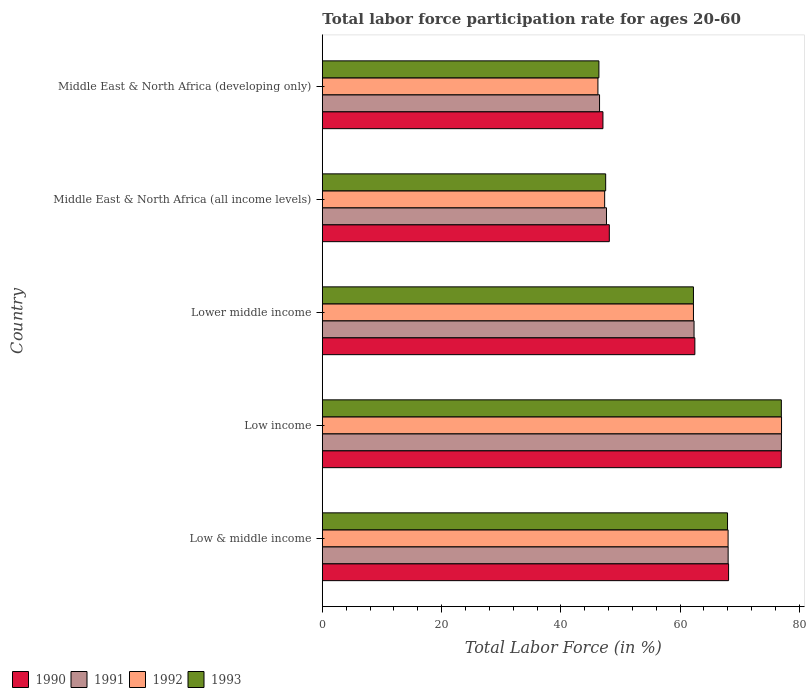How many different coloured bars are there?
Keep it short and to the point. 4. Are the number of bars per tick equal to the number of legend labels?
Provide a short and direct response. Yes. In how many cases, is the number of bars for a given country not equal to the number of legend labels?
Offer a very short reply. 0. What is the labor force participation rate in 1991 in Middle East & North Africa (developing only)?
Your answer should be compact. 46.49. Across all countries, what is the maximum labor force participation rate in 1990?
Provide a short and direct response. 76.96. Across all countries, what is the minimum labor force participation rate in 1991?
Your answer should be very brief. 46.49. In which country was the labor force participation rate in 1991 minimum?
Give a very brief answer. Middle East & North Africa (developing only). What is the total labor force participation rate in 1992 in the graph?
Offer a very short reply. 300.85. What is the difference between the labor force participation rate in 1991 in Low & middle income and that in Low income?
Ensure brevity in your answer.  -8.94. What is the difference between the labor force participation rate in 1992 in Middle East & North Africa (all income levels) and the labor force participation rate in 1990 in Low income?
Offer a very short reply. -29.62. What is the average labor force participation rate in 1993 per country?
Give a very brief answer. 60.21. What is the difference between the labor force participation rate in 1991 and labor force participation rate in 1992 in Middle East & North Africa (all income levels)?
Keep it short and to the point. 0.31. What is the ratio of the labor force participation rate in 1992 in Low & middle income to that in Middle East & North Africa (developing only)?
Offer a very short reply. 1.47. What is the difference between the highest and the second highest labor force participation rate in 1993?
Give a very brief answer. 9.03. What is the difference between the highest and the lowest labor force participation rate in 1991?
Keep it short and to the point. 30.5. What does the 4th bar from the top in Middle East & North Africa (developing only) represents?
Keep it short and to the point. 1990. What does the 1st bar from the bottom in Middle East & North Africa (developing only) represents?
Keep it short and to the point. 1990. Is it the case that in every country, the sum of the labor force participation rate in 1991 and labor force participation rate in 1993 is greater than the labor force participation rate in 1992?
Make the answer very short. Yes. How many bars are there?
Make the answer very short. 20. Are all the bars in the graph horizontal?
Offer a very short reply. Yes. What is the difference between two consecutive major ticks on the X-axis?
Provide a succinct answer. 20. Does the graph contain grids?
Your response must be concise. No. Where does the legend appear in the graph?
Provide a short and direct response. Bottom left. How many legend labels are there?
Make the answer very short. 4. What is the title of the graph?
Ensure brevity in your answer.  Total labor force participation rate for ages 20-60. Does "2010" appear as one of the legend labels in the graph?
Your answer should be compact. No. What is the label or title of the Y-axis?
Your answer should be compact. Country. What is the Total Labor Force (in %) of 1990 in Low & middle income?
Ensure brevity in your answer.  68.13. What is the Total Labor Force (in %) in 1991 in Low & middle income?
Provide a succinct answer. 68.05. What is the Total Labor Force (in %) of 1992 in Low & middle income?
Offer a terse response. 68.05. What is the Total Labor Force (in %) in 1993 in Low & middle income?
Offer a very short reply. 67.95. What is the Total Labor Force (in %) in 1990 in Low income?
Your answer should be compact. 76.96. What is the Total Labor Force (in %) of 1991 in Low income?
Give a very brief answer. 76.99. What is the Total Labor Force (in %) of 1992 in Low income?
Ensure brevity in your answer.  77.01. What is the Total Labor Force (in %) in 1993 in Low income?
Make the answer very short. 76.98. What is the Total Labor Force (in %) of 1990 in Lower middle income?
Keep it short and to the point. 62.47. What is the Total Labor Force (in %) of 1991 in Lower middle income?
Your response must be concise. 62.34. What is the Total Labor Force (in %) of 1992 in Lower middle income?
Ensure brevity in your answer.  62.24. What is the Total Labor Force (in %) of 1993 in Lower middle income?
Give a very brief answer. 62.24. What is the Total Labor Force (in %) of 1990 in Middle East & North Africa (all income levels)?
Make the answer very short. 48.13. What is the Total Labor Force (in %) in 1991 in Middle East & North Africa (all income levels)?
Your answer should be very brief. 47.65. What is the Total Labor Force (in %) in 1992 in Middle East & North Africa (all income levels)?
Ensure brevity in your answer.  47.34. What is the Total Labor Force (in %) in 1993 in Middle East & North Africa (all income levels)?
Provide a short and direct response. 47.51. What is the Total Labor Force (in %) of 1990 in Middle East & North Africa (developing only)?
Offer a terse response. 47.06. What is the Total Labor Force (in %) of 1991 in Middle East & North Africa (developing only)?
Make the answer very short. 46.49. What is the Total Labor Force (in %) in 1992 in Middle East & North Africa (developing only)?
Provide a short and direct response. 46.22. What is the Total Labor Force (in %) in 1993 in Middle East & North Africa (developing only)?
Keep it short and to the point. 46.38. Across all countries, what is the maximum Total Labor Force (in %) in 1990?
Give a very brief answer. 76.96. Across all countries, what is the maximum Total Labor Force (in %) of 1991?
Your answer should be compact. 76.99. Across all countries, what is the maximum Total Labor Force (in %) in 1992?
Offer a very short reply. 77.01. Across all countries, what is the maximum Total Labor Force (in %) of 1993?
Your answer should be very brief. 76.98. Across all countries, what is the minimum Total Labor Force (in %) in 1990?
Provide a succinct answer. 47.06. Across all countries, what is the minimum Total Labor Force (in %) in 1991?
Provide a short and direct response. 46.49. Across all countries, what is the minimum Total Labor Force (in %) in 1992?
Provide a succinct answer. 46.22. Across all countries, what is the minimum Total Labor Force (in %) in 1993?
Your answer should be compact. 46.38. What is the total Total Labor Force (in %) of 1990 in the graph?
Your response must be concise. 302.75. What is the total Total Labor Force (in %) in 1991 in the graph?
Give a very brief answer. 301.52. What is the total Total Labor Force (in %) of 1992 in the graph?
Give a very brief answer. 300.85. What is the total Total Labor Force (in %) in 1993 in the graph?
Your answer should be very brief. 301.06. What is the difference between the Total Labor Force (in %) in 1990 in Low & middle income and that in Low income?
Give a very brief answer. -8.84. What is the difference between the Total Labor Force (in %) of 1991 in Low & middle income and that in Low income?
Provide a short and direct response. -8.94. What is the difference between the Total Labor Force (in %) in 1992 in Low & middle income and that in Low income?
Your response must be concise. -8.96. What is the difference between the Total Labor Force (in %) of 1993 in Low & middle income and that in Low income?
Offer a terse response. -9.03. What is the difference between the Total Labor Force (in %) in 1990 in Low & middle income and that in Lower middle income?
Provide a succinct answer. 5.65. What is the difference between the Total Labor Force (in %) of 1991 in Low & middle income and that in Lower middle income?
Your answer should be very brief. 5.72. What is the difference between the Total Labor Force (in %) in 1992 in Low & middle income and that in Lower middle income?
Keep it short and to the point. 5.81. What is the difference between the Total Labor Force (in %) of 1993 in Low & middle income and that in Lower middle income?
Your answer should be very brief. 5.71. What is the difference between the Total Labor Force (in %) of 1990 in Low & middle income and that in Middle East & North Africa (all income levels)?
Keep it short and to the point. 20. What is the difference between the Total Labor Force (in %) of 1991 in Low & middle income and that in Middle East & North Africa (all income levels)?
Give a very brief answer. 20.4. What is the difference between the Total Labor Force (in %) in 1992 in Low & middle income and that in Middle East & North Africa (all income levels)?
Provide a succinct answer. 20.7. What is the difference between the Total Labor Force (in %) of 1993 in Low & middle income and that in Middle East & North Africa (all income levels)?
Ensure brevity in your answer.  20.44. What is the difference between the Total Labor Force (in %) in 1990 in Low & middle income and that in Middle East & North Africa (developing only)?
Your response must be concise. 21.07. What is the difference between the Total Labor Force (in %) of 1991 in Low & middle income and that in Middle East & North Africa (developing only)?
Provide a short and direct response. 21.56. What is the difference between the Total Labor Force (in %) in 1992 in Low & middle income and that in Middle East & North Africa (developing only)?
Make the answer very short. 21.83. What is the difference between the Total Labor Force (in %) of 1993 in Low & middle income and that in Middle East & North Africa (developing only)?
Your response must be concise. 21.57. What is the difference between the Total Labor Force (in %) of 1990 in Low income and that in Lower middle income?
Ensure brevity in your answer.  14.49. What is the difference between the Total Labor Force (in %) in 1991 in Low income and that in Lower middle income?
Offer a very short reply. 14.65. What is the difference between the Total Labor Force (in %) of 1992 in Low income and that in Lower middle income?
Provide a short and direct response. 14.77. What is the difference between the Total Labor Force (in %) of 1993 in Low income and that in Lower middle income?
Give a very brief answer. 14.74. What is the difference between the Total Labor Force (in %) in 1990 in Low income and that in Middle East & North Africa (all income levels)?
Offer a very short reply. 28.84. What is the difference between the Total Labor Force (in %) in 1991 in Low income and that in Middle East & North Africa (all income levels)?
Offer a terse response. 29.34. What is the difference between the Total Labor Force (in %) of 1992 in Low income and that in Middle East & North Africa (all income levels)?
Provide a short and direct response. 29.66. What is the difference between the Total Labor Force (in %) of 1993 in Low income and that in Middle East & North Africa (all income levels)?
Your answer should be compact. 29.46. What is the difference between the Total Labor Force (in %) in 1990 in Low income and that in Middle East & North Africa (developing only)?
Keep it short and to the point. 29.91. What is the difference between the Total Labor Force (in %) in 1991 in Low income and that in Middle East & North Africa (developing only)?
Keep it short and to the point. 30.5. What is the difference between the Total Labor Force (in %) of 1992 in Low income and that in Middle East & North Africa (developing only)?
Your response must be concise. 30.79. What is the difference between the Total Labor Force (in %) of 1993 in Low income and that in Middle East & North Africa (developing only)?
Make the answer very short. 30.6. What is the difference between the Total Labor Force (in %) of 1990 in Lower middle income and that in Middle East & North Africa (all income levels)?
Your response must be concise. 14.35. What is the difference between the Total Labor Force (in %) of 1991 in Lower middle income and that in Middle East & North Africa (all income levels)?
Provide a short and direct response. 14.69. What is the difference between the Total Labor Force (in %) of 1992 in Lower middle income and that in Middle East & North Africa (all income levels)?
Your answer should be very brief. 14.89. What is the difference between the Total Labor Force (in %) of 1993 in Lower middle income and that in Middle East & North Africa (all income levels)?
Your answer should be compact. 14.72. What is the difference between the Total Labor Force (in %) in 1990 in Lower middle income and that in Middle East & North Africa (developing only)?
Your answer should be compact. 15.41. What is the difference between the Total Labor Force (in %) in 1991 in Lower middle income and that in Middle East & North Africa (developing only)?
Offer a terse response. 15.85. What is the difference between the Total Labor Force (in %) in 1992 in Lower middle income and that in Middle East & North Africa (developing only)?
Provide a succinct answer. 16.02. What is the difference between the Total Labor Force (in %) in 1993 in Lower middle income and that in Middle East & North Africa (developing only)?
Ensure brevity in your answer.  15.86. What is the difference between the Total Labor Force (in %) in 1990 in Middle East & North Africa (all income levels) and that in Middle East & North Africa (developing only)?
Provide a short and direct response. 1.07. What is the difference between the Total Labor Force (in %) of 1991 in Middle East & North Africa (all income levels) and that in Middle East & North Africa (developing only)?
Keep it short and to the point. 1.16. What is the difference between the Total Labor Force (in %) of 1992 in Middle East & North Africa (all income levels) and that in Middle East & North Africa (developing only)?
Keep it short and to the point. 1.13. What is the difference between the Total Labor Force (in %) of 1993 in Middle East & North Africa (all income levels) and that in Middle East & North Africa (developing only)?
Keep it short and to the point. 1.13. What is the difference between the Total Labor Force (in %) in 1990 in Low & middle income and the Total Labor Force (in %) in 1991 in Low income?
Give a very brief answer. -8.86. What is the difference between the Total Labor Force (in %) in 1990 in Low & middle income and the Total Labor Force (in %) in 1992 in Low income?
Provide a short and direct response. -8.88. What is the difference between the Total Labor Force (in %) of 1990 in Low & middle income and the Total Labor Force (in %) of 1993 in Low income?
Your answer should be compact. -8.85. What is the difference between the Total Labor Force (in %) of 1991 in Low & middle income and the Total Labor Force (in %) of 1992 in Low income?
Offer a terse response. -8.95. What is the difference between the Total Labor Force (in %) of 1991 in Low & middle income and the Total Labor Force (in %) of 1993 in Low income?
Keep it short and to the point. -8.92. What is the difference between the Total Labor Force (in %) in 1992 in Low & middle income and the Total Labor Force (in %) in 1993 in Low income?
Your response must be concise. -8.93. What is the difference between the Total Labor Force (in %) of 1990 in Low & middle income and the Total Labor Force (in %) of 1991 in Lower middle income?
Offer a very short reply. 5.79. What is the difference between the Total Labor Force (in %) of 1990 in Low & middle income and the Total Labor Force (in %) of 1992 in Lower middle income?
Your answer should be compact. 5.89. What is the difference between the Total Labor Force (in %) of 1990 in Low & middle income and the Total Labor Force (in %) of 1993 in Lower middle income?
Your answer should be compact. 5.89. What is the difference between the Total Labor Force (in %) in 1991 in Low & middle income and the Total Labor Force (in %) in 1992 in Lower middle income?
Offer a terse response. 5.82. What is the difference between the Total Labor Force (in %) of 1991 in Low & middle income and the Total Labor Force (in %) of 1993 in Lower middle income?
Offer a terse response. 5.82. What is the difference between the Total Labor Force (in %) of 1992 in Low & middle income and the Total Labor Force (in %) of 1993 in Lower middle income?
Your answer should be compact. 5.81. What is the difference between the Total Labor Force (in %) of 1990 in Low & middle income and the Total Labor Force (in %) of 1991 in Middle East & North Africa (all income levels)?
Provide a short and direct response. 20.48. What is the difference between the Total Labor Force (in %) of 1990 in Low & middle income and the Total Labor Force (in %) of 1992 in Middle East & North Africa (all income levels)?
Your response must be concise. 20.78. What is the difference between the Total Labor Force (in %) in 1990 in Low & middle income and the Total Labor Force (in %) in 1993 in Middle East & North Africa (all income levels)?
Offer a terse response. 20.61. What is the difference between the Total Labor Force (in %) of 1991 in Low & middle income and the Total Labor Force (in %) of 1992 in Middle East & North Africa (all income levels)?
Offer a very short reply. 20.71. What is the difference between the Total Labor Force (in %) in 1991 in Low & middle income and the Total Labor Force (in %) in 1993 in Middle East & North Africa (all income levels)?
Offer a terse response. 20.54. What is the difference between the Total Labor Force (in %) of 1992 in Low & middle income and the Total Labor Force (in %) of 1993 in Middle East & North Africa (all income levels)?
Make the answer very short. 20.53. What is the difference between the Total Labor Force (in %) of 1990 in Low & middle income and the Total Labor Force (in %) of 1991 in Middle East & North Africa (developing only)?
Your answer should be compact. 21.64. What is the difference between the Total Labor Force (in %) in 1990 in Low & middle income and the Total Labor Force (in %) in 1992 in Middle East & North Africa (developing only)?
Give a very brief answer. 21.91. What is the difference between the Total Labor Force (in %) of 1990 in Low & middle income and the Total Labor Force (in %) of 1993 in Middle East & North Africa (developing only)?
Your response must be concise. 21.75. What is the difference between the Total Labor Force (in %) of 1991 in Low & middle income and the Total Labor Force (in %) of 1992 in Middle East & North Africa (developing only)?
Provide a short and direct response. 21.84. What is the difference between the Total Labor Force (in %) of 1991 in Low & middle income and the Total Labor Force (in %) of 1993 in Middle East & North Africa (developing only)?
Your answer should be very brief. 21.67. What is the difference between the Total Labor Force (in %) in 1992 in Low & middle income and the Total Labor Force (in %) in 1993 in Middle East & North Africa (developing only)?
Ensure brevity in your answer.  21.66. What is the difference between the Total Labor Force (in %) in 1990 in Low income and the Total Labor Force (in %) in 1991 in Lower middle income?
Make the answer very short. 14.63. What is the difference between the Total Labor Force (in %) in 1990 in Low income and the Total Labor Force (in %) in 1992 in Lower middle income?
Keep it short and to the point. 14.73. What is the difference between the Total Labor Force (in %) in 1990 in Low income and the Total Labor Force (in %) in 1993 in Lower middle income?
Give a very brief answer. 14.73. What is the difference between the Total Labor Force (in %) in 1991 in Low income and the Total Labor Force (in %) in 1992 in Lower middle income?
Provide a short and direct response. 14.75. What is the difference between the Total Labor Force (in %) in 1991 in Low income and the Total Labor Force (in %) in 1993 in Lower middle income?
Offer a terse response. 14.75. What is the difference between the Total Labor Force (in %) in 1992 in Low income and the Total Labor Force (in %) in 1993 in Lower middle income?
Provide a succinct answer. 14.77. What is the difference between the Total Labor Force (in %) of 1990 in Low income and the Total Labor Force (in %) of 1991 in Middle East & North Africa (all income levels)?
Give a very brief answer. 29.31. What is the difference between the Total Labor Force (in %) in 1990 in Low income and the Total Labor Force (in %) in 1992 in Middle East & North Africa (all income levels)?
Offer a terse response. 29.62. What is the difference between the Total Labor Force (in %) in 1990 in Low income and the Total Labor Force (in %) in 1993 in Middle East & North Africa (all income levels)?
Provide a short and direct response. 29.45. What is the difference between the Total Labor Force (in %) in 1991 in Low income and the Total Labor Force (in %) in 1992 in Middle East & North Africa (all income levels)?
Provide a succinct answer. 29.64. What is the difference between the Total Labor Force (in %) in 1991 in Low income and the Total Labor Force (in %) in 1993 in Middle East & North Africa (all income levels)?
Offer a terse response. 29.47. What is the difference between the Total Labor Force (in %) of 1992 in Low income and the Total Labor Force (in %) of 1993 in Middle East & North Africa (all income levels)?
Keep it short and to the point. 29.49. What is the difference between the Total Labor Force (in %) of 1990 in Low income and the Total Labor Force (in %) of 1991 in Middle East & North Africa (developing only)?
Provide a short and direct response. 30.47. What is the difference between the Total Labor Force (in %) of 1990 in Low income and the Total Labor Force (in %) of 1992 in Middle East & North Africa (developing only)?
Provide a short and direct response. 30.75. What is the difference between the Total Labor Force (in %) in 1990 in Low income and the Total Labor Force (in %) in 1993 in Middle East & North Africa (developing only)?
Make the answer very short. 30.58. What is the difference between the Total Labor Force (in %) of 1991 in Low income and the Total Labor Force (in %) of 1992 in Middle East & North Africa (developing only)?
Make the answer very short. 30.77. What is the difference between the Total Labor Force (in %) in 1991 in Low income and the Total Labor Force (in %) in 1993 in Middle East & North Africa (developing only)?
Ensure brevity in your answer.  30.61. What is the difference between the Total Labor Force (in %) of 1992 in Low income and the Total Labor Force (in %) of 1993 in Middle East & North Africa (developing only)?
Make the answer very short. 30.63. What is the difference between the Total Labor Force (in %) in 1990 in Lower middle income and the Total Labor Force (in %) in 1991 in Middle East & North Africa (all income levels)?
Offer a very short reply. 14.82. What is the difference between the Total Labor Force (in %) of 1990 in Lower middle income and the Total Labor Force (in %) of 1992 in Middle East & North Africa (all income levels)?
Offer a terse response. 15.13. What is the difference between the Total Labor Force (in %) of 1990 in Lower middle income and the Total Labor Force (in %) of 1993 in Middle East & North Africa (all income levels)?
Give a very brief answer. 14.96. What is the difference between the Total Labor Force (in %) of 1991 in Lower middle income and the Total Labor Force (in %) of 1992 in Middle East & North Africa (all income levels)?
Offer a very short reply. 14.99. What is the difference between the Total Labor Force (in %) of 1991 in Lower middle income and the Total Labor Force (in %) of 1993 in Middle East & North Africa (all income levels)?
Provide a succinct answer. 14.82. What is the difference between the Total Labor Force (in %) in 1992 in Lower middle income and the Total Labor Force (in %) in 1993 in Middle East & North Africa (all income levels)?
Offer a terse response. 14.72. What is the difference between the Total Labor Force (in %) of 1990 in Lower middle income and the Total Labor Force (in %) of 1991 in Middle East & North Africa (developing only)?
Provide a succinct answer. 15.98. What is the difference between the Total Labor Force (in %) in 1990 in Lower middle income and the Total Labor Force (in %) in 1992 in Middle East & North Africa (developing only)?
Keep it short and to the point. 16.26. What is the difference between the Total Labor Force (in %) of 1990 in Lower middle income and the Total Labor Force (in %) of 1993 in Middle East & North Africa (developing only)?
Your answer should be compact. 16.09. What is the difference between the Total Labor Force (in %) in 1991 in Lower middle income and the Total Labor Force (in %) in 1992 in Middle East & North Africa (developing only)?
Your answer should be compact. 16.12. What is the difference between the Total Labor Force (in %) in 1991 in Lower middle income and the Total Labor Force (in %) in 1993 in Middle East & North Africa (developing only)?
Provide a short and direct response. 15.96. What is the difference between the Total Labor Force (in %) in 1992 in Lower middle income and the Total Labor Force (in %) in 1993 in Middle East & North Africa (developing only)?
Give a very brief answer. 15.86. What is the difference between the Total Labor Force (in %) in 1990 in Middle East & North Africa (all income levels) and the Total Labor Force (in %) in 1991 in Middle East & North Africa (developing only)?
Offer a terse response. 1.64. What is the difference between the Total Labor Force (in %) of 1990 in Middle East & North Africa (all income levels) and the Total Labor Force (in %) of 1992 in Middle East & North Africa (developing only)?
Your response must be concise. 1.91. What is the difference between the Total Labor Force (in %) in 1990 in Middle East & North Africa (all income levels) and the Total Labor Force (in %) in 1993 in Middle East & North Africa (developing only)?
Your answer should be very brief. 1.75. What is the difference between the Total Labor Force (in %) of 1991 in Middle East & North Africa (all income levels) and the Total Labor Force (in %) of 1992 in Middle East & North Africa (developing only)?
Make the answer very short. 1.43. What is the difference between the Total Labor Force (in %) of 1991 in Middle East & North Africa (all income levels) and the Total Labor Force (in %) of 1993 in Middle East & North Africa (developing only)?
Provide a succinct answer. 1.27. What is the difference between the Total Labor Force (in %) of 1992 in Middle East & North Africa (all income levels) and the Total Labor Force (in %) of 1993 in Middle East & North Africa (developing only)?
Offer a very short reply. 0.96. What is the average Total Labor Force (in %) of 1990 per country?
Your response must be concise. 60.55. What is the average Total Labor Force (in %) in 1991 per country?
Offer a terse response. 60.3. What is the average Total Labor Force (in %) of 1992 per country?
Give a very brief answer. 60.17. What is the average Total Labor Force (in %) in 1993 per country?
Your response must be concise. 60.21. What is the difference between the Total Labor Force (in %) of 1990 and Total Labor Force (in %) of 1991 in Low & middle income?
Provide a succinct answer. 0.07. What is the difference between the Total Labor Force (in %) of 1990 and Total Labor Force (in %) of 1992 in Low & middle income?
Your response must be concise. 0.08. What is the difference between the Total Labor Force (in %) of 1990 and Total Labor Force (in %) of 1993 in Low & middle income?
Give a very brief answer. 0.18. What is the difference between the Total Labor Force (in %) of 1991 and Total Labor Force (in %) of 1992 in Low & middle income?
Provide a short and direct response. 0.01. What is the difference between the Total Labor Force (in %) in 1991 and Total Labor Force (in %) in 1993 in Low & middle income?
Your answer should be compact. 0.1. What is the difference between the Total Labor Force (in %) in 1992 and Total Labor Force (in %) in 1993 in Low & middle income?
Your answer should be compact. 0.1. What is the difference between the Total Labor Force (in %) of 1990 and Total Labor Force (in %) of 1991 in Low income?
Your answer should be very brief. -0.03. What is the difference between the Total Labor Force (in %) in 1990 and Total Labor Force (in %) in 1992 in Low income?
Your answer should be very brief. -0.04. What is the difference between the Total Labor Force (in %) of 1990 and Total Labor Force (in %) of 1993 in Low income?
Provide a succinct answer. -0.01. What is the difference between the Total Labor Force (in %) of 1991 and Total Labor Force (in %) of 1992 in Low income?
Offer a terse response. -0.02. What is the difference between the Total Labor Force (in %) of 1991 and Total Labor Force (in %) of 1993 in Low income?
Your response must be concise. 0.01. What is the difference between the Total Labor Force (in %) of 1992 and Total Labor Force (in %) of 1993 in Low income?
Offer a very short reply. 0.03. What is the difference between the Total Labor Force (in %) in 1990 and Total Labor Force (in %) in 1991 in Lower middle income?
Ensure brevity in your answer.  0.14. What is the difference between the Total Labor Force (in %) in 1990 and Total Labor Force (in %) in 1992 in Lower middle income?
Your answer should be very brief. 0.24. What is the difference between the Total Labor Force (in %) in 1990 and Total Labor Force (in %) in 1993 in Lower middle income?
Your answer should be compact. 0.24. What is the difference between the Total Labor Force (in %) of 1991 and Total Labor Force (in %) of 1992 in Lower middle income?
Your answer should be very brief. 0.1. What is the difference between the Total Labor Force (in %) of 1991 and Total Labor Force (in %) of 1993 in Lower middle income?
Your response must be concise. 0.1. What is the difference between the Total Labor Force (in %) in 1992 and Total Labor Force (in %) in 1993 in Lower middle income?
Keep it short and to the point. 0. What is the difference between the Total Labor Force (in %) of 1990 and Total Labor Force (in %) of 1991 in Middle East & North Africa (all income levels)?
Give a very brief answer. 0.48. What is the difference between the Total Labor Force (in %) of 1990 and Total Labor Force (in %) of 1992 in Middle East & North Africa (all income levels)?
Your answer should be very brief. 0.78. What is the difference between the Total Labor Force (in %) of 1990 and Total Labor Force (in %) of 1993 in Middle East & North Africa (all income levels)?
Ensure brevity in your answer.  0.61. What is the difference between the Total Labor Force (in %) in 1991 and Total Labor Force (in %) in 1992 in Middle East & North Africa (all income levels)?
Keep it short and to the point. 0.31. What is the difference between the Total Labor Force (in %) of 1991 and Total Labor Force (in %) of 1993 in Middle East & North Africa (all income levels)?
Offer a terse response. 0.14. What is the difference between the Total Labor Force (in %) of 1992 and Total Labor Force (in %) of 1993 in Middle East & North Africa (all income levels)?
Keep it short and to the point. -0.17. What is the difference between the Total Labor Force (in %) in 1990 and Total Labor Force (in %) in 1991 in Middle East & North Africa (developing only)?
Provide a succinct answer. 0.57. What is the difference between the Total Labor Force (in %) in 1990 and Total Labor Force (in %) in 1992 in Middle East & North Africa (developing only)?
Offer a terse response. 0.84. What is the difference between the Total Labor Force (in %) in 1990 and Total Labor Force (in %) in 1993 in Middle East & North Africa (developing only)?
Provide a succinct answer. 0.68. What is the difference between the Total Labor Force (in %) of 1991 and Total Labor Force (in %) of 1992 in Middle East & North Africa (developing only)?
Provide a succinct answer. 0.27. What is the difference between the Total Labor Force (in %) of 1991 and Total Labor Force (in %) of 1993 in Middle East & North Africa (developing only)?
Provide a succinct answer. 0.11. What is the difference between the Total Labor Force (in %) of 1992 and Total Labor Force (in %) of 1993 in Middle East & North Africa (developing only)?
Provide a succinct answer. -0.16. What is the ratio of the Total Labor Force (in %) of 1990 in Low & middle income to that in Low income?
Provide a short and direct response. 0.89. What is the ratio of the Total Labor Force (in %) in 1991 in Low & middle income to that in Low income?
Give a very brief answer. 0.88. What is the ratio of the Total Labor Force (in %) in 1992 in Low & middle income to that in Low income?
Offer a very short reply. 0.88. What is the ratio of the Total Labor Force (in %) in 1993 in Low & middle income to that in Low income?
Your answer should be compact. 0.88. What is the ratio of the Total Labor Force (in %) in 1990 in Low & middle income to that in Lower middle income?
Ensure brevity in your answer.  1.09. What is the ratio of the Total Labor Force (in %) in 1991 in Low & middle income to that in Lower middle income?
Your answer should be compact. 1.09. What is the ratio of the Total Labor Force (in %) of 1992 in Low & middle income to that in Lower middle income?
Give a very brief answer. 1.09. What is the ratio of the Total Labor Force (in %) in 1993 in Low & middle income to that in Lower middle income?
Your answer should be very brief. 1.09. What is the ratio of the Total Labor Force (in %) of 1990 in Low & middle income to that in Middle East & North Africa (all income levels)?
Ensure brevity in your answer.  1.42. What is the ratio of the Total Labor Force (in %) of 1991 in Low & middle income to that in Middle East & North Africa (all income levels)?
Provide a short and direct response. 1.43. What is the ratio of the Total Labor Force (in %) in 1992 in Low & middle income to that in Middle East & North Africa (all income levels)?
Your answer should be compact. 1.44. What is the ratio of the Total Labor Force (in %) of 1993 in Low & middle income to that in Middle East & North Africa (all income levels)?
Make the answer very short. 1.43. What is the ratio of the Total Labor Force (in %) in 1990 in Low & middle income to that in Middle East & North Africa (developing only)?
Keep it short and to the point. 1.45. What is the ratio of the Total Labor Force (in %) of 1991 in Low & middle income to that in Middle East & North Africa (developing only)?
Your answer should be compact. 1.46. What is the ratio of the Total Labor Force (in %) of 1992 in Low & middle income to that in Middle East & North Africa (developing only)?
Provide a succinct answer. 1.47. What is the ratio of the Total Labor Force (in %) in 1993 in Low & middle income to that in Middle East & North Africa (developing only)?
Your answer should be very brief. 1.47. What is the ratio of the Total Labor Force (in %) in 1990 in Low income to that in Lower middle income?
Offer a terse response. 1.23. What is the ratio of the Total Labor Force (in %) of 1991 in Low income to that in Lower middle income?
Your answer should be very brief. 1.24. What is the ratio of the Total Labor Force (in %) in 1992 in Low income to that in Lower middle income?
Provide a succinct answer. 1.24. What is the ratio of the Total Labor Force (in %) in 1993 in Low income to that in Lower middle income?
Ensure brevity in your answer.  1.24. What is the ratio of the Total Labor Force (in %) in 1990 in Low income to that in Middle East & North Africa (all income levels)?
Offer a terse response. 1.6. What is the ratio of the Total Labor Force (in %) in 1991 in Low income to that in Middle East & North Africa (all income levels)?
Provide a short and direct response. 1.62. What is the ratio of the Total Labor Force (in %) of 1992 in Low income to that in Middle East & North Africa (all income levels)?
Offer a terse response. 1.63. What is the ratio of the Total Labor Force (in %) in 1993 in Low income to that in Middle East & North Africa (all income levels)?
Offer a very short reply. 1.62. What is the ratio of the Total Labor Force (in %) of 1990 in Low income to that in Middle East & North Africa (developing only)?
Provide a succinct answer. 1.64. What is the ratio of the Total Labor Force (in %) of 1991 in Low income to that in Middle East & North Africa (developing only)?
Your answer should be compact. 1.66. What is the ratio of the Total Labor Force (in %) of 1992 in Low income to that in Middle East & North Africa (developing only)?
Keep it short and to the point. 1.67. What is the ratio of the Total Labor Force (in %) of 1993 in Low income to that in Middle East & North Africa (developing only)?
Offer a terse response. 1.66. What is the ratio of the Total Labor Force (in %) in 1990 in Lower middle income to that in Middle East & North Africa (all income levels)?
Offer a very short reply. 1.3. What is the ratio of the Total Labor Force (in %) in 1991 in Lower middle income to that in Middle East & North Africa (all income levels)?
Keep it short and to the point. 1.31. What is the ratio of the Total Labor Force (in %) in 1992 in Lower middle income to that in Middle East & North Africa (all income levels)?
Offer a terse response. 1.31. What is the ratio of the Total Labor Force (in %) in 1993 in Lower middle income to that in Middle East & North Africa (all income levels)?
Offer a terse response. 1.31. What is the ratio of the Total Labor Force (in %) in 1990 in Lower middle income to that in Middle East & North Africa (developing only)?
Provide a succinct answer. 1.33. What is the ratio of the Total Labor Force (in %) in 1991 in Lower middle income to that in Middle East & North Africa (developing only)?
Provide a short and direct response. 1.34. What is the ratio of the Total Labor Force (in %) of 1992 in Lower middle income to that in Middle East & North Africa (developing only)?
Provide a succinct answer. 1.35. What is the ratio of the Total Labor Force (in %) in 1993 in Lower middle income to that in Middle East & North Africa (developing only)?
Your answer should be very brief. 1.34. What is the ratio of the Total Labor Force (in %) in 1990 in Middle East & North Africa (all income levels) to that in Middle East & North Africa (developing only)?
Offer a terse response. 1.02. What is the ratio of the Total Labor Force (in %) of 1992 in Middle East & North Africa (all income levels) to that in Middle East & North Africa (developing only)?
Your response must be concise. 1.02. What is the ratio of the Total Labor Force (in %) in 1993 in Middle East & North Africa (all income levels) to that in Middle East & North Africa (developing only)?
Offer a very short reply. 1.02. What is the difference between the highest and the second highest Total Labor Force (in %) of 1990?
Ensure brevity in your answer.  8.84. What is the difference between the highest and the second highest Total Labor Force (in %) of 1991?
Keep it short and to the point. 8.94. What is the difference between the highest and the second highest Total Labor Force (in %) in 1992?
Your answer should be compact. 8.96. What is the difference between the highest and the second highest Total Labor Force (in %) of 1993?
Provide a short and direct response. 9.03. What is the difference between the highest and the lowest Total Labor Force (in %) in 1990?
Give a very brief answer. 29.91. What is the difference between the highest and the lowest Total Labor Force (in %) of 1991?
Your answer should be very brief. 30.5. What is the difference between the highest and the lowest Total Labor Force (in %) in 1992?
Your answer should be very brief. 30.79. What is the difference between the highest and the lowest Total Labor Force (in %) in 1993?
Offer a very short reply. 30.6. 